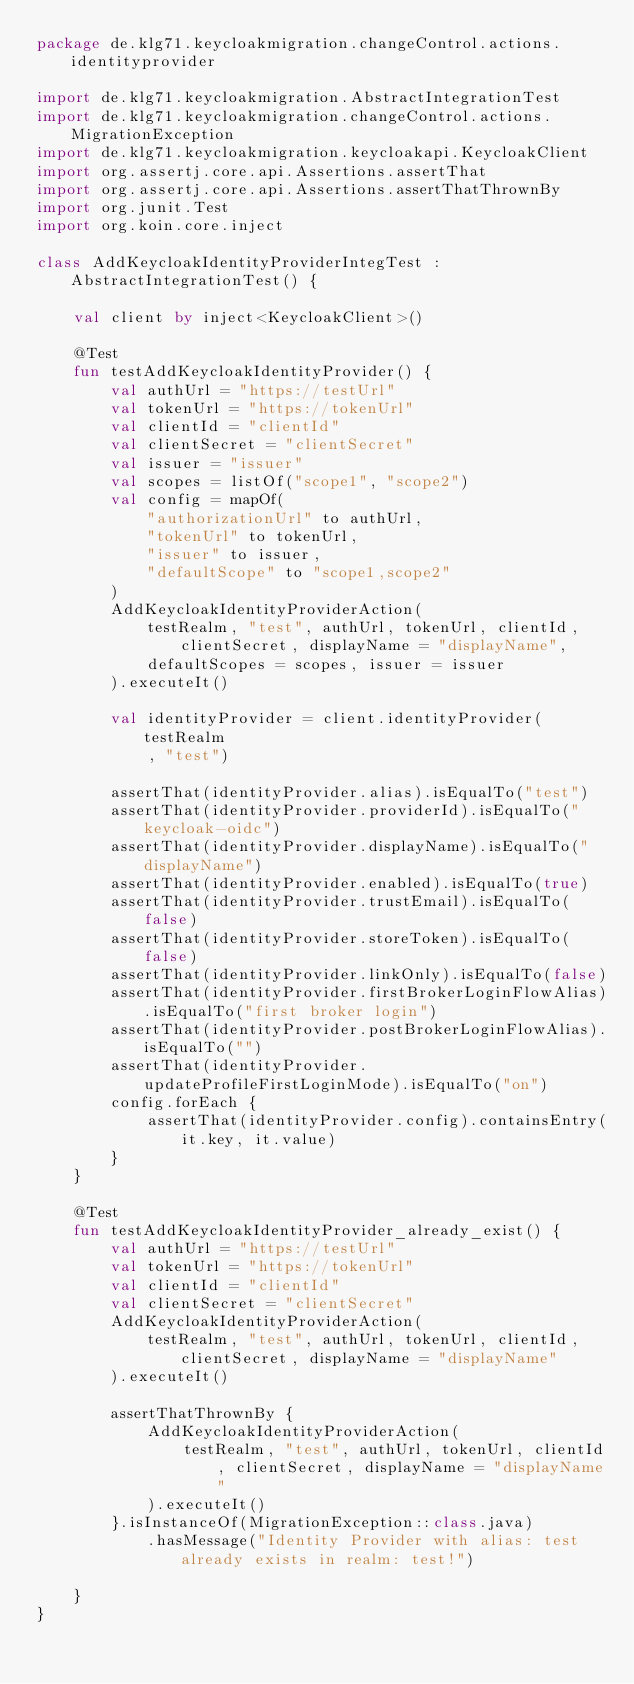<code> <loc_0><loc_0><loc_500><loc_500><_Kotlin_>package de.klg71.keycloakmigration.changeControl.actions.identityprovider

import de.klg71.keycloakmigration.AbstractIntegrationTest
import de.klg71.keycloakmigration.changeControl.actions.MigrationException
import de.klg71.keycloakmigration.keycloakapi.KeycloakClient
import org.assertj.core.api.Assertions.assertThat
import org.assertj.core.api.Assertions.assertThatThrownBy
import org.junit.Test
import org.koin.core.inject

class AddKeycloakIdentityProviderIntegTest : AbstractIntegrationTest() {

    val client by inject<KeycloakClient>()

    @Test
    fun testAddKeycloakIdentityProvider() {
        val authUrl = "https://testUrl"
        val tokenUrl = "https://tokenUrl"
        val clientId = "clientId"
        val clientSecret = "clientSecret"
        val issuer = "issuer"
        val scopes = listOf("scope1", "scope2")
        val config = mapOf(
            "authorizationUrl" to authUrl,
            "tokenUrl" to tokenUrl,
            "issuer" to issuer,
            "defaultScope" to "scope1,scope2"
        )
        AddKeycloakIdentityProviderAction(
            testRealm, "test", authUrl, tokenUrl, clientId, clientSecret, displayName = "displayName",
            defaultScopes = scopes, issuer = issuer
        ).executeIt()

        val identityProvider = client.identityProvider(testRealm
            , "test")

        assertThat(identityProvider.alias).isEqualTo("test")
        assertThat(identityProvider.providerId).isEqualTo("keycloak-oidc")
        assertThat(identityProvider.displayName).isEqualTo("displayName")
        assertThat(identityProvider.enabled).isEqualTo(true)
        assertThat(identityProvider.trustEmail).isEqualTo(false)
        assertThat(identityProvider.storeToken).isEqualTo(false)
        assertThat(identityProvider.linkOnly).isEqualTo(false)
        assertThat(identityProvider.firstBrokerLoginFlowAlias).isEqualTo("first broker login")
        assertThat(identityProvider.postBrokerLoginFlowAlias).isEqualTo("")
        assertThat(identityProvider.updateProfileFirstLoginMode).isEqualTo("on")
        config.forEach {
            assertThat(identityProvider.config).containsEntry(it.key, it.value)
        }
    }

    @Test
    fun testAddKeycloakIdentityProvider_already_exist() {
        val authUrl = "https://testUrl"
        val tokenUrl = "https://tokenUrl"
        val clientId = "clientId"
        val clientSecret = "clientSecret"
        AddKeycloakIdentityProviderAction(
            testRealm, "test", authUrl, tokenUrl, clientId, clientSecret, displayName = "displayName"
        ).executeIt()

        assertThatThrownBy {
            AddKeycloakIdentityProviderAction(
                testRealm, "test", authUrl, tokenUrl, clientId, clientSecret, displayName = "displayName"
            ).executeIt()
        }.isInstanceOf(MigrationException::class.java)
            .hasMessage("Identity Provider with alias: test already exists in realm: test!")

    }
}
</code> 